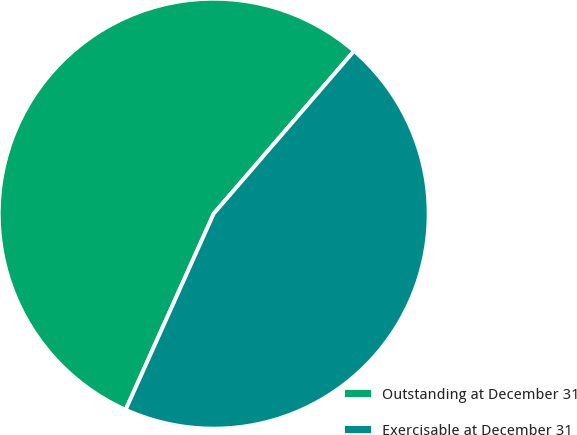Convert chart. <chart><loc_0><loc_0><loc_500><loc_500><pie_chart><fcel>Outstanding at December 31<fcel>Exercisable at December 31<nl><fcel>54.61%<fcel>45.39%<nl></chart> 